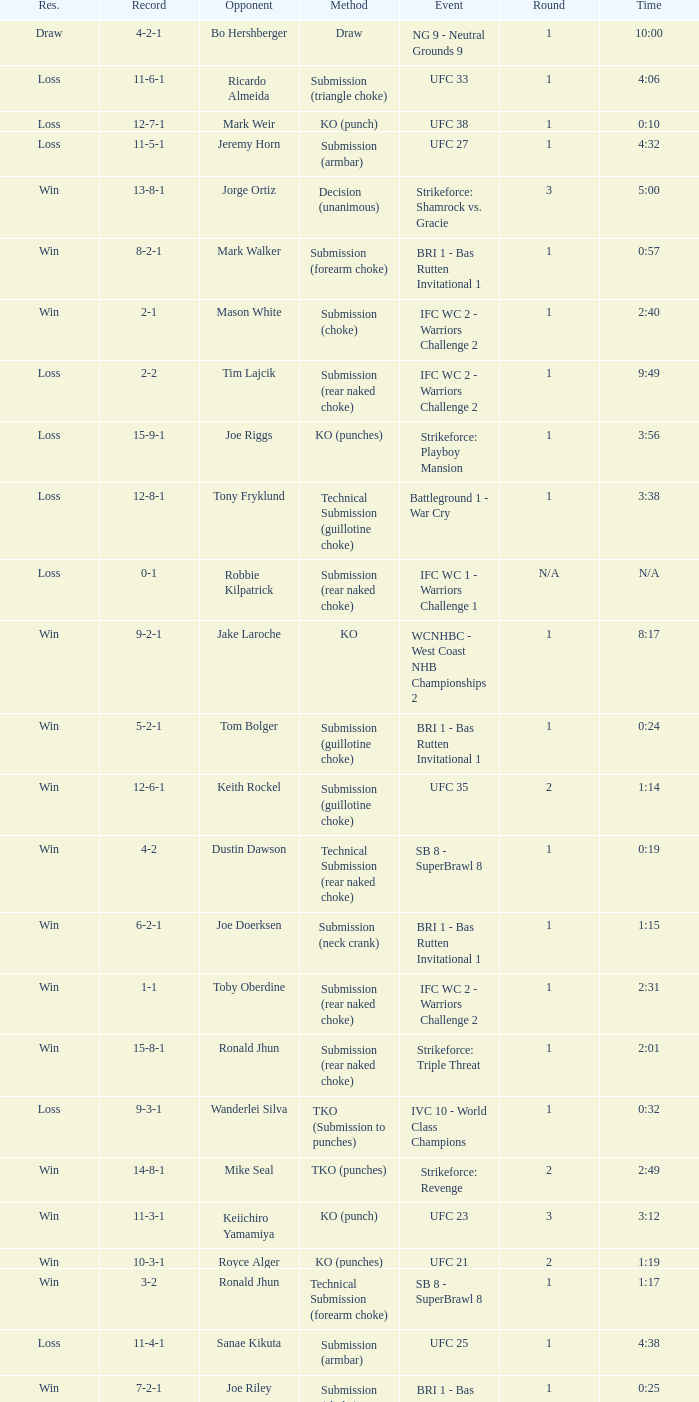Who was the opponent when the fight had a time of 0:10? Mark Weir. Write the full table. {'header': ['Res.', 'Record', 'Opponent', 'Method', 'Event', 'Round', 'Time'], 'rows': [['Draw', '4-2-1', 'Bo Hershberger', 'Draw', 'NG 9 - Neutral Grounds 9', '1', '10:00'], ['Loss', '11-6-1', 'Ricardo Almeida', 'Submission (triangle choke)', 'UFC 33', '1', '4:06'], ['Loss', '12-7-1', 'Mark Weir', 'KO (punch)', 'UFC 38', '1', '0:10'], ['Loss', '11-5-1', 'Jeremy Horn', 'Submission (armbar)', 'UFC 27', '1', '4:32'], ['Win', '13-8-1', 'Jorge Ortiz', 'Decision (unanimous)', 'Strikeforce: Shamrock vs. Gracie', '3', '5:00'], ['Win', '8-2-1', 'Mark Walker', 'Submission (forearm choke)', 'BRI 1 - Bas Rutten Invitational 1', '1', '0:57'], ['Win', '2-1', 'Mason White', 'Submission (choke)', 'IFC WC 2 - Warriors Challenge 2', '1', '2:40'], ['Loss', '2-2', 'Tim Lajcik', 'Submission (rear naked choke)', 'IFC WC 2 - Warriors Challenge 2', '1', '9:49'], ['Loss', '15-9-1', 'Joe Riggs', 'KO (punches)', 'Strikeforce: Playboy Mansion', '1', '3:56'], ['Loss', '12-8-1', 'Tony Fryklund', 'Technical Submission (guillotine choke)', 'Battleground 1 - War Cry', '1', '3:38'], ['Loss', '0-1', 'Robbie Kilpatrick', 'Submission (rear naked choke)', 'IFC WC 1 - Warriors Challenge 1', 'N/A', 'N/A'], ['Win', '9-2-1', 'Jake Laroche', 'KO', 'WCNHBC - West Coast NHB Championships 2', '1', '8:17'], ['Win', '5-2-1', 'Tom Bolger', 'Submission (guillotine choke)', 'BRI 1 - Bas Rutten Invitational 1', '1', '0:24'], ['Win', '12-6-1', 'Keith Rockel', 'Submission (guillotine choke)', 'UFC 35', '2', '1:14'], ['Win', '4-2', 'Dustin Dawson', 'Technical Submission (rear naked choke)', 'SB 8 - SuperBrawl 8', '1', '0:19'], ['Win', '6-2-1', 'Joe Doerksen', 'Submission (neck crank)', 'BRI 1 - Bas Rutten Invitational 1', '1', '1:15'], ['Win', '1-1', 'Toby Oberdine', 'Submission (rear naked choke)', 'IFC WC 2 - Warriors Challenge 2', '1', '2:31'], ['Win', '15-8-1', 'Ronald Jhun', 'Submission (rear naked choke)', 'Strikeforce: Triple Threat', '1', '2:01'], ['Loss', '9-3-1', 'Wanderlei Silva', 'TKO (Submission to punches)', 'IVC 10 - World Class Champions', '1', '0:32'], ['Win', '14-8-1', 'Mike Seal', 'TKO (punches)', 'Strikeforce: Revenge', '2', '2:49'], ['Win', '11-3-1', 'Keiichiro Yamamiya', 'KO (punch)', 'UFC 23', '3', '3:12'], ['Win', '10-3-1', 'Royce Alger', 'KO (punches)', 'UFC 21', '2', '1:19'], ['Win', '3-2', 'Ronald Jhun', 'Technical Submission (forearm choke)', 'SB 8 - SuperBrawl 8', '1', '1:17'], ['Loss', '11-4-1', 'Sanae Kikuta', 'Submission (armbar)', 'UFC 25', '1', '4:38'], ['Win', '7-2-1', 'Joe Riley', 'Submission (choke)', 'BRI 1 - Bas Rutten Invitational 1', '1', '0:25']]} 